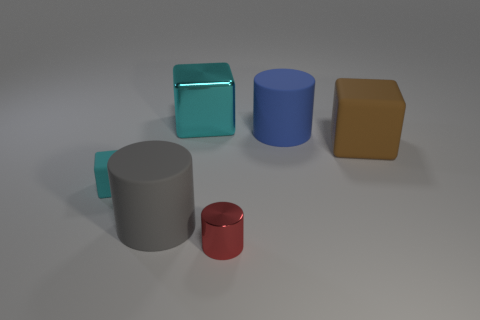How many red things are either small blocks or matte cubes?
Your response must be concise. 0. The large cyan shiny thing has what shape?
Your answer should be compact. Cube. What number of other things are there of the same shape as the red thing?
Make the answer very short. 2. What is the color of the large rubber object to the left of the large shiny cube?
Make the answer very short. Gray. Is the material of the big gray cylinder the same as the small red thing?
Your answer should be very brief. No. How many objects are either large gray matte cylinders or big objects that are to the right of the large metallic block?
Give a very brief answer. 3. There is a metallic object that is the same color as the small cube; what size is it?
Provide a succinct answer. Large. The metal thing behind the gray rubber object has what shape?
Provide a succinct answer. Cube. Do the matte cylinder that is to the right of the tiny red metallic object and the tiny metallic object have the same color?
Your answer should be compact. No. There is a large thing that is the same color as the small matte thing; what material is it?
Make the answer very short. Metal. 